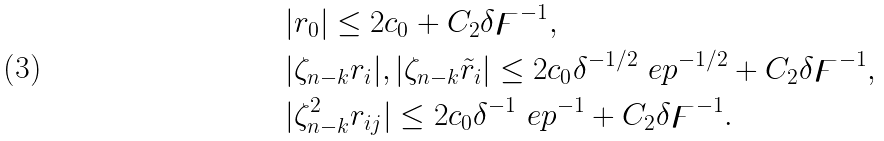<formula> <loc_0><loc_0><loc_500><loc_500>& | r _ { 0 } | \leq 2 c _ { 0 } + C _ { 2 } \delta \digamma ^ { - 1 } , \\ & | \zeta _ { n - k } r _ { i } | , | \zeta _ { n - k } \tilde { r } _ { i } | \leq 2 c _ { 0 } \delta ^ { - 1 / 2 } \ e p ^ { - 1 / 2 } + C _ { 2 } \delta \digamma ^ { - 1 } , \\ & | \zeta _ { n - k } ^ { 2 } r _ { i j } | \leq 2 c _ { 0 } \delta ^ { - 1 } \ e p ^ { - 1 } + C _ { 2 } \delta \digamma ^ { - 1 } .</formula> 